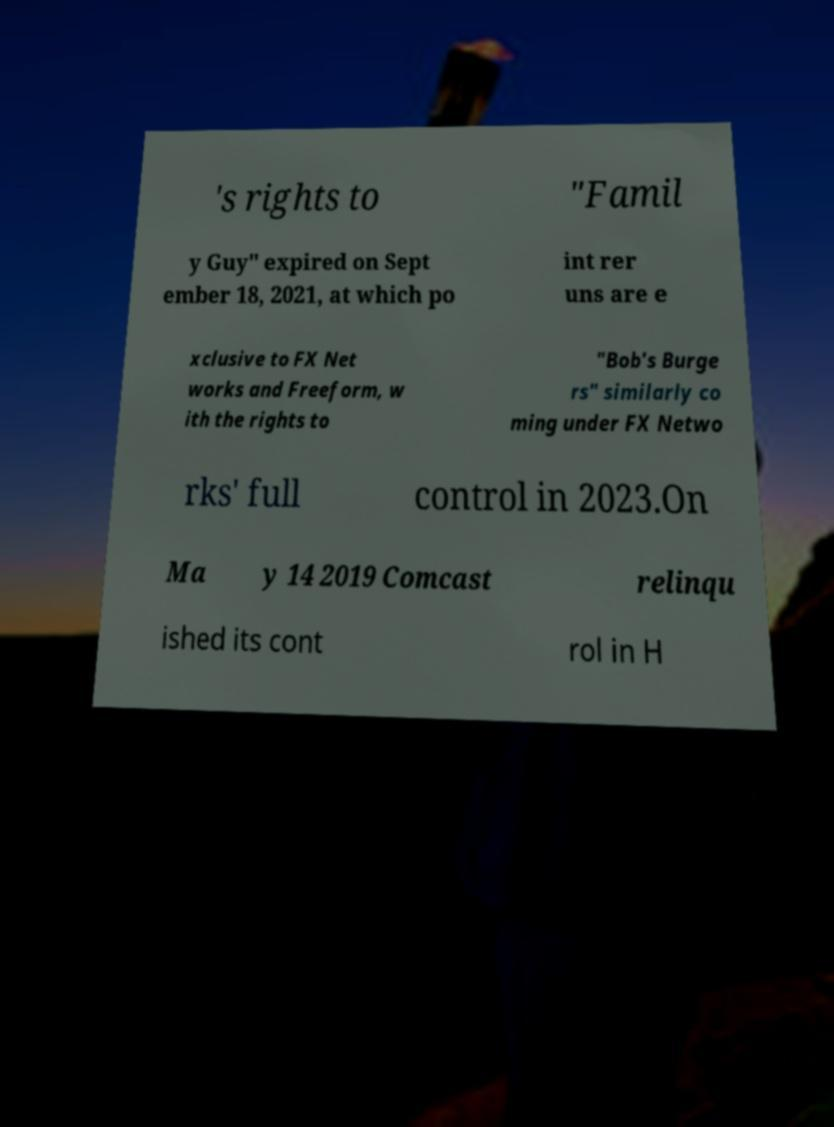Could you extract and type out the text from this image? 's rights to "Famil y Guy" expired on Sept ember 18, 2021, at which po int rer uns are e xclusive to FX Net works and Freeform, w ith the rights to "Bob's Burge rs" similarly co ming under FX Netwo rks' full control in 2023.On Ma y 14 2019 Comcast relinqu ished its cont rol in H 